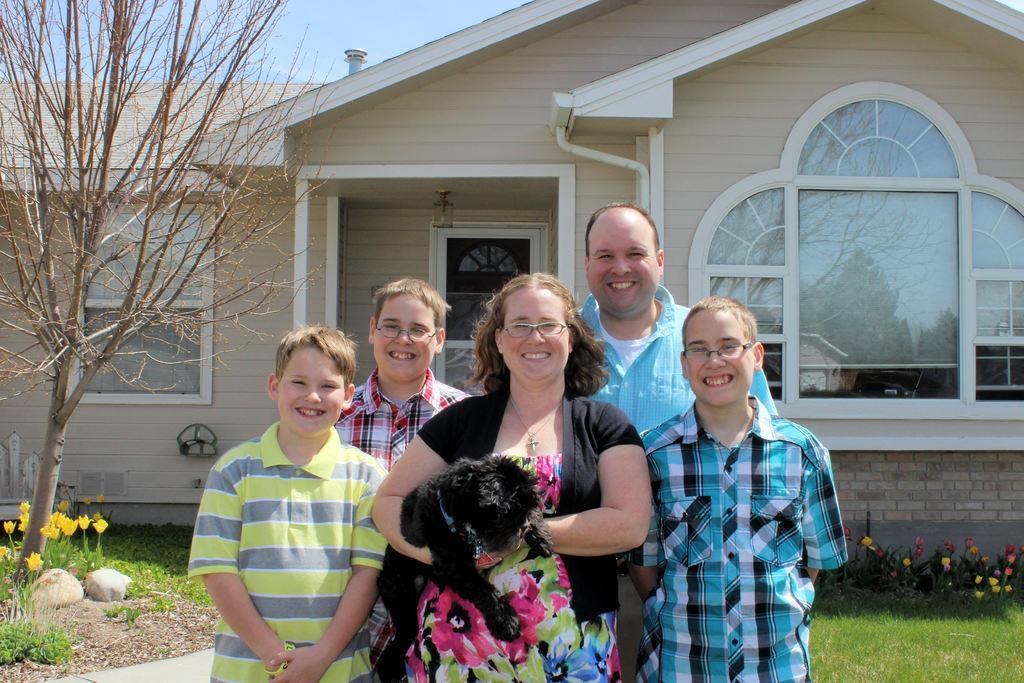In one or two sentences, can you explain what this image depicts? This picture describes about group five people and a dog, in the middle of the image a woman is holding a dog in her hand, in the background we can see a house and a tree. 